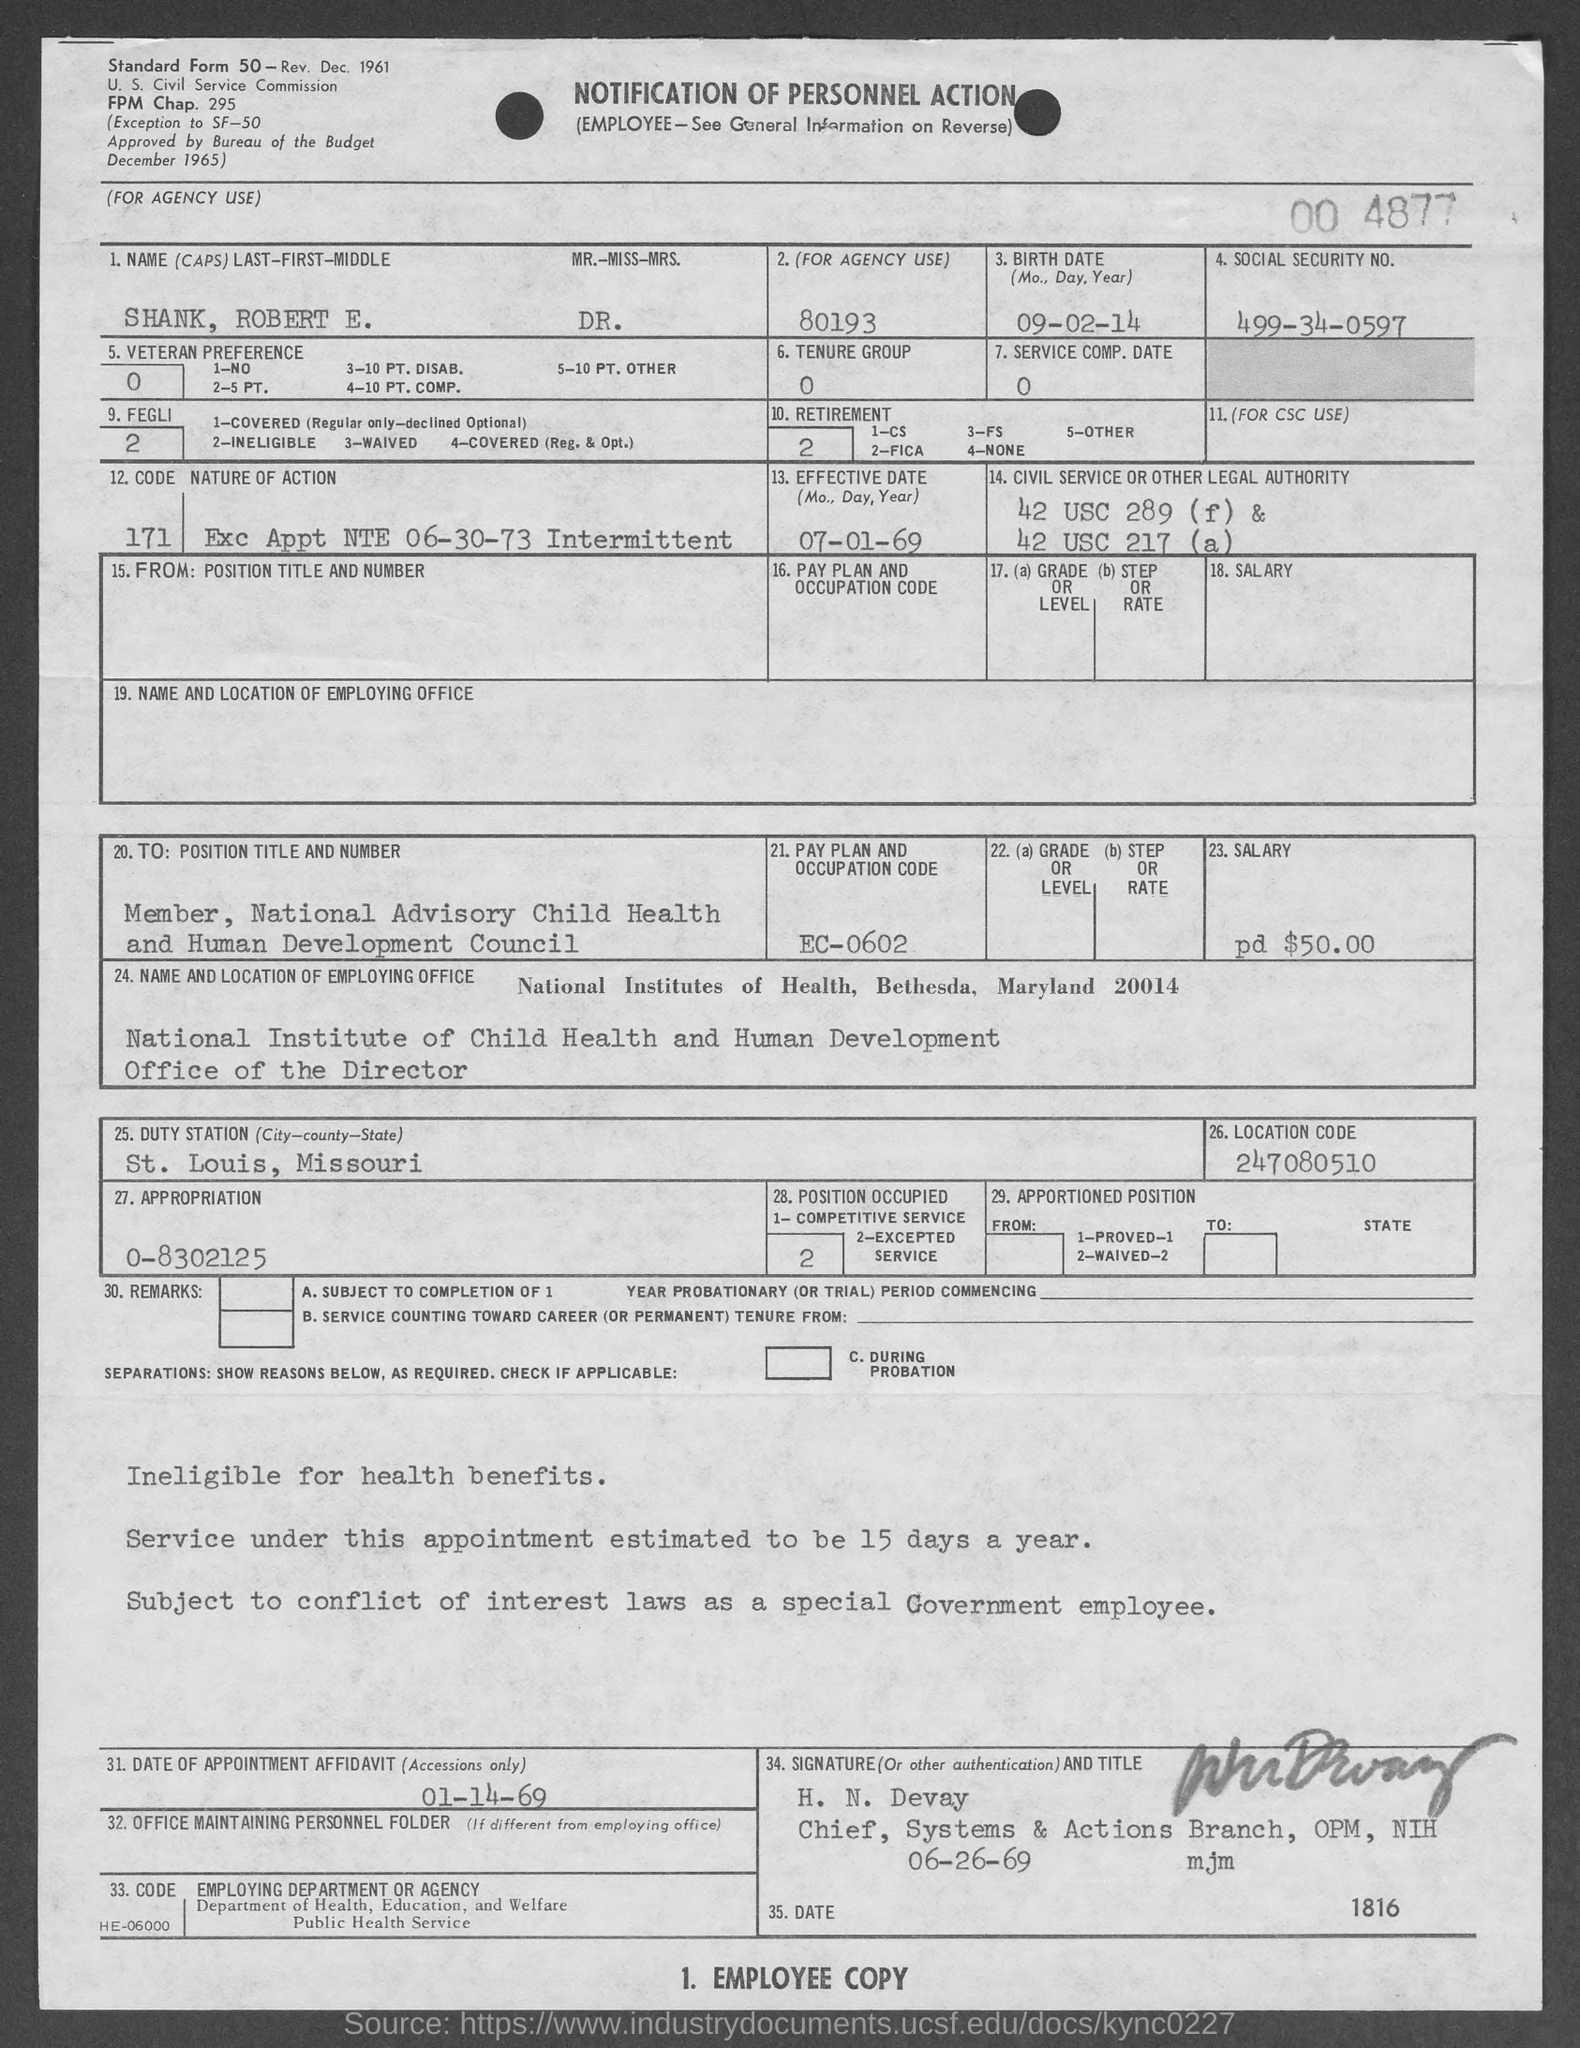What does the term 'Intermittent' refer to in the context of this employment notification? The term 'Intermittent' on the employment notification means that the employment is not continuous or regular. It may involve working on an as-needed basis, and the specifics can vary widely, often depending on the employer’s needs and the particulars of the job. 